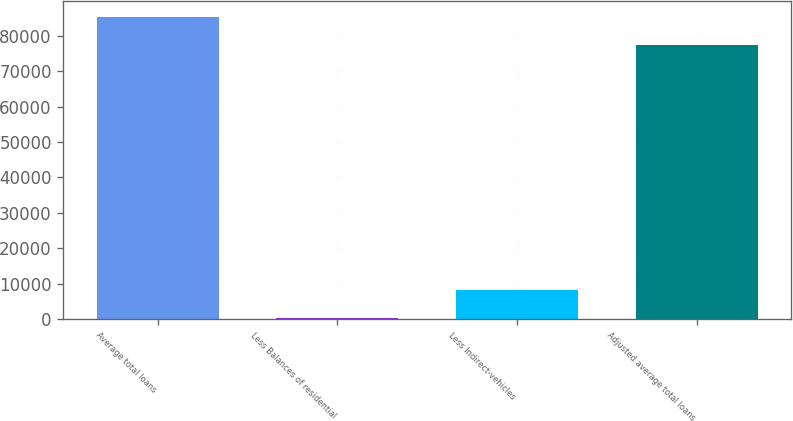Convert chart. <chart><loc_0><loc_0><loc_500><loc_500><bar_chart><fcel>Average total loans<fcel>Less Balances of residential<fcel>Less Indirect-vehicles<fcel>Adjusted average total loans<nl><fcel>85388<fcel>254<fcel>8192<fcel>77450<nl></chart> 